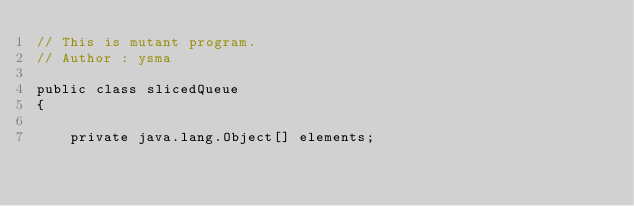Convert code to text. <code><loc_0><loc_0><loc_500><loc_500><_Java_>// This is mutant program.
// Author : ysma

public class slicedQueue
{

    private java.lang.Object[] elements;
</code> 